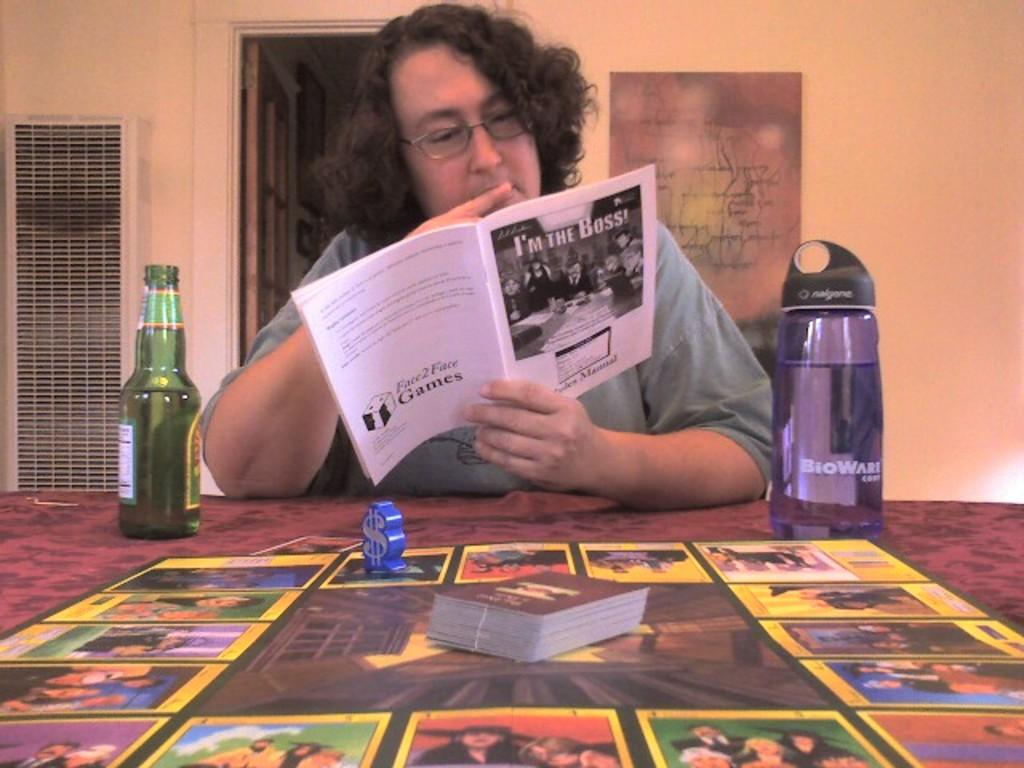Provide a one-sentence caption for the provided image. A man with a beer, reading the instructions for the game "I'm the Boss.". 